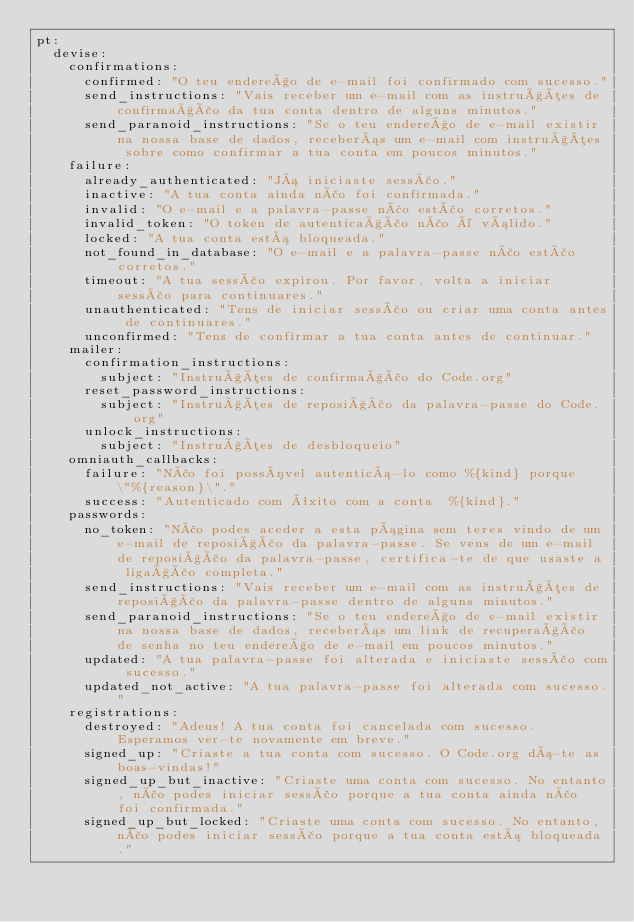Convert code to text. <code><loc_0><loc_0><loc_500><loc_500><_YAML_>pt:
  devise:
    confirmations:
      confirmed: "O teu endereço de e-mail foi confirmado com sucesso."
      send_instructions: "Vais receber um e-mail com as instruções de confirmação da tua conta dentro de alguns minutos."
      send_paranoid_instructions: "Se o teu endereço de e-mail existir na nossa base de dados, receberás um e-mail com instruções sobre como confirmar a tua conta em poucos minutos."
    failure:
      already_authenticated: "Já iniciaste sessão."
      inactive: "A tua conta ainda não foi confirmada."
      invalid: "O e-mail e a palavra-passe não estão corretos."
      invalid_token: "O token de autenticação não é válido."
      locked: "A tua conta está bloqueada."
      not_found_in_database: "O e-mail e a palavra-passe não estão corretos."
      timeout: "A tua sessão expirou. Por favor, volta a iniciar sessão para continuares."
      unauthenticated: "Tens de iniciar sessão ou criar uma conta antes de continuares."
      unconfirmed: "Tens de confirmar a tua conta antes de continuar."
    mailer:
      confirmation_instructions:
        subject: "Instruções de confirmação do Code.org"
      reset_password_instructions:
        subject: "Instruções de reposição da palavra-passe do Code.org"
      unlock_instructions:
        subject: "Instruções de desbloqueio"
    omniauth_callbacks:
      failure: "Não foi possível autenticá-lo como %{kind} porque \"%{reason}\"."
      success: "Autenticado com êxito com a conta  %{kind}."
    passwords:
      no_token: "Não podes aceder a esta página sem teres vindo de um e-mail de reposição da palavra-passe. Se vens de um e-mail de reposição da palavra-passe, certifica-te de que usaste a ligação completa."
      send_instructions: "Vais receber um e-mail com as instruções de reposição da palavra-passe dentro de alguns minutos."
      send_paranoid_instructions: "Se o teu endereço de e-mail existir na nossa base de dados, receberás um link de recuperação de senha no teu endereço de e-mail em poucos minutos."
      updated: "A tua palavra-passe foi alterada e iniciaste sessão com sucesso."
      updated_not_active: "A tua palavra-passe foi alterada com sucesso."
    registrations:
      destroyed: "Adeus! A tua conta foi cancelada com sucesso. Esperamos ver-te novamente em breve."
      signed_up: "Criaste a tua conta com sucesso. O Code.org dá-te as boas-vindas!"
      signed_up_but_inactive: "Criaste uma conta com sucesso. No entanto, não podes iniciar sessão porque a tua conta ainda não foi confirmada."
      signed_up_but_locked: "Criaste uma conta com sucesso. No entanto, não podes iniciar sessão porque a tua conta está bloqueada."</code> 